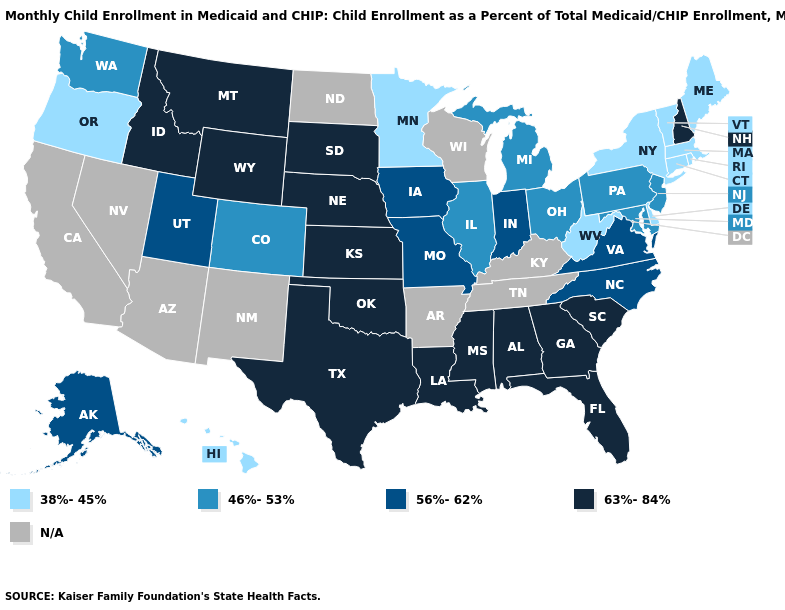What is the value of Arizona?
Short answer required. N/A. Name the states that have a value in the range 63%-84%?
Answer briefly. Alabama, Florida, Georgia, Idaho, Kansas, Louisiana, Mississippi, Montana, Nebraska, New Hampshire, Oklahoma, South Carolina, South Dakota, Texas, Wyoming. Name the states that have a value in the range 63%-84%?
Answer briefly. Alabama, Florida, Georgia, Idaho, Kansas, Louisiana, Mississippi, Montana, Nebraska, New Hampshire, Oklahoma, South Carolina, South Dakota, Texas, Wyoming. Does Oregon have the lowest value in the West?
Answer briefly. Yes. Does Nebraska have the lowest value in the MidWest?
Concise answer only. No. Name the states that have a value in the range 63%-84%?
Short answer required. Alabama, Florida, Georgia, Idaho, Kansas, Louisiana, Mississippi, Montana, Nebraska, New Hampshire, Oklahoma, South Carolina, South Dakota, Texas, Wyoming. Which states hav the highest value in the Northeast?
Give a very brief answer. New Hampshire. Name the states that have a value in the range 63%-84%?
Quick response, please. Alabama, Florida, Georgia, Idaho, Kansas, Louisiana, Mississippi, Montana, Nebraska, New Hampshire, Oklahoma, South Carolina, South Dakota, Texas, Wyoming. Name the states that have a value in the range 38%-45%?
Keep it brief. Connecticut, Delaware, Hawaii, Maine, Massachusetts, Minnesota, New York, Oregon, Rhode Island, Vermont, West Virginia. What is the value of Mississippi?
Concise answer only. 63%-84%. What is the highest value in the West ?
Be succinct. 63%-84%. Name the states that have a value in the range 56%-62%?
Keep it brief. Alaska, Indiana, Iowa, Missouri, North Carolina, Utah, Virginia. What is the highest value in the South ?
Concise answer only. 63%-84%. What is the value of Nevada?
Concise answer only. N/A. Name the states that have a value in the range N/A?
Write a very short answer. Arizona, Arkansas, California, Kentucky, Nevada, New Mexico, North Dakota, Tennessee, Wisconsin. 